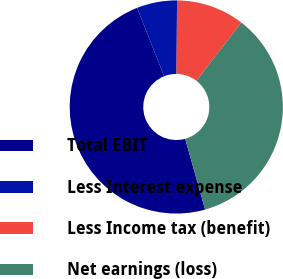Convert chart to OTSL. <chart><loc_0><loc_0><loc_500><loc_500><pie_chart><fcel>Total EBIT<fcel>Less Interest expense<fcel>Less Income tax (benefit)<fcel>Net earnings (loss)<nl><fcel>48.36%<fcel>6.11%<fcel>10.33%<fcel>35.2%<nl></chart> 